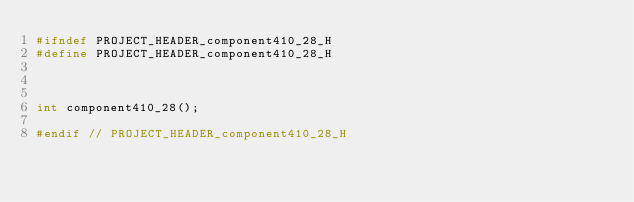<code> <loc_0><loc_0><loc_500><loc_500><_C_>#ifndef PROJECT_HEADER_component410_28_H
#define PROJECT_HEADER_component410_28_H



int component410_28();

#endif // PROJECT_HEADER_component410_28_H</code> 